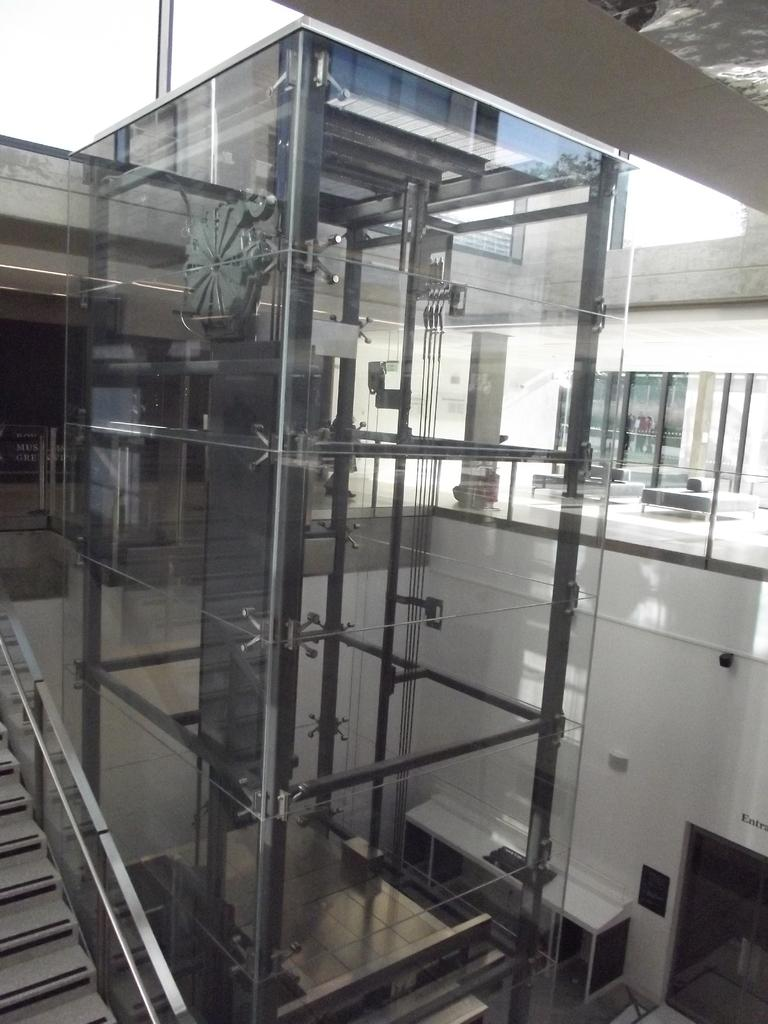What type of location is depicted in the image? The image is an inside view of a building. What structural elements can be seen in the image? There are iron rods and stairs visible in the image. What type of transportation is available in the building? There is a passenger lift in the image. What can be seen in the background of the image? The sky is visible in the background of the image. What type of toy is being used for breakfast in the image? There is no toy or breakfast depicted in the image; it shows an inside view of a building with iron rods, stairs, a passenger lift, and a visible sky in the background. What vegetables are being grown in the image? There are no vegetables or gardening activities shown in the image. 